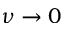<formula> <loc_0><loc_0><loc_500><loc_500>\nu \rightarrow 0</formula> 